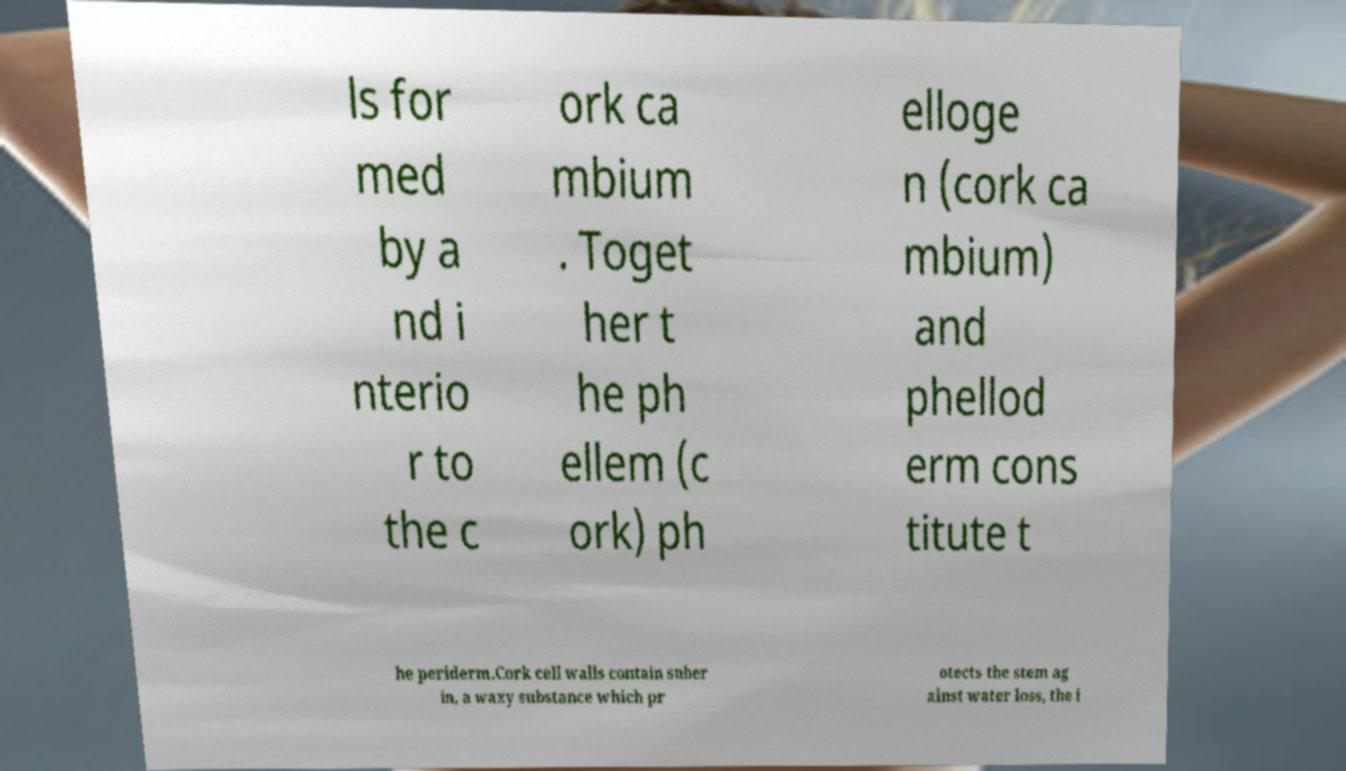There's text embedded in this image that I need extracted. Can you transcribe it verbatim? ls for med by a nd i nterio r to the c ork ca mbium . Toget her t he ph ellem (c ork) ph elloge n (cork ca mbium) and phellod erm cons titute t he periderm.Cork cell walls contain suber in, a waxy substance which pr otects the stem ag ainst water loss, the i 